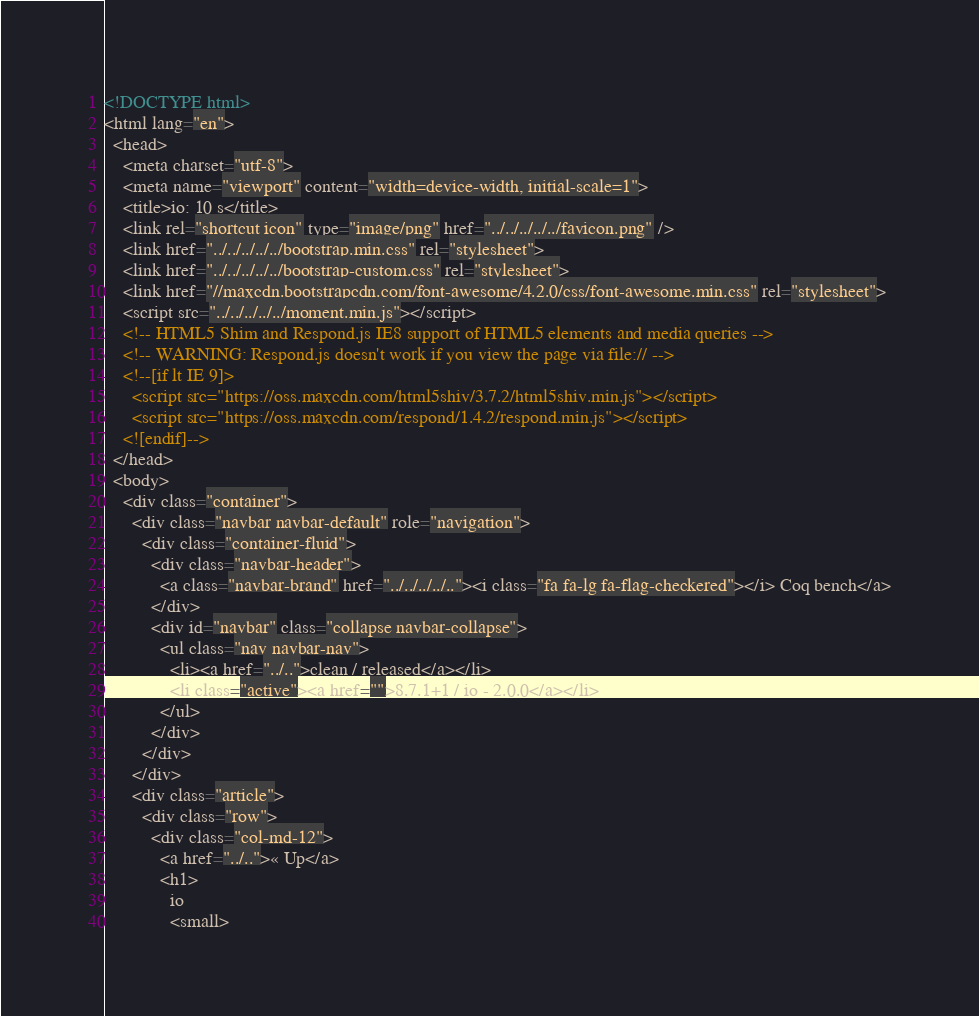<code> <loc_0><loc_0><loc_500><loc_500><_HTML_><!DOCTYPE html>
<html lang="en">
  <head>
    <meta charset="utf-8">
    <meta name="viewport" content="width=device-width, initial-scale=1">
    <title>io: 10 s</title>
    <link rel="shortcut icon" type="image/png" href="../../../../../favicon.png" />
    <link href="../../../../../bootstrap.min.css" rel="stylesheet">
    <link href="../../../../../bootstrap-custom.css" rel="stylesheet">
    <link href="//maxcdn.bootstrapcdn.com/font-awesome/4.2.0/css/font-awesome.min.css" rel="stylesheet">
    <script src="../../../../../moment.min.js"></script>
    <!-- HTML5 Shim and Respond.js IE8 support of HTML5 elements and media queries -->
    <!-- WARNING: Respond.js doesn't work if you view the page via file:// -->
    <!--[if lt IE 9]>
      <script src="https://oss.maxcdn.com/html5shiv/3.7.2/html5shiv.min.js"></script>
      <script src="https://oss.maxcdn.com/respond/1.4.2/respond.min.js"></script>
    <![endif]-->
  </head>
  <body>
    <div class="container">
      <div class="navbar navbar-default" role="navigation">
        <div class="container-fluid">
          <div class="navbar-header">
            <a class="navbar-brand" href="../../../../.."><i class="fa fa-lg fa-flag-checkered"></i> Coq bench</a>
          </div>
          <div id="navbar" class="collapse navbar-collapse">
            <ul class="nav navbar-nav">
              <li><a href="../..">clean / released</a></li>
              <li class="active"><a href="">8.7.1+1 / io - 2.0.0</a></li>
            </ul>
          </div>
        </div>
      </div>
      <div class="article">
        <div class="row">
          <div class="col-md-12">
            <a href="../..">« Up</a>
            <h1>
              io
              <small></code> 